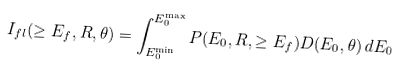<formula> <loc_0><loc_0><loc_500><loc_500>I _ { f l } ( \geq E _ { f } , R , \theta ) = \int _ { E ^ { \min } _ { 0 } } ^ { E ^ { \max } _ { 0 } } { P ( E _ { 0 } , R , \geq E _ { f } ) D ( E _ { 0 } , \theta ) \, d E _ { 0 } }</formula> 